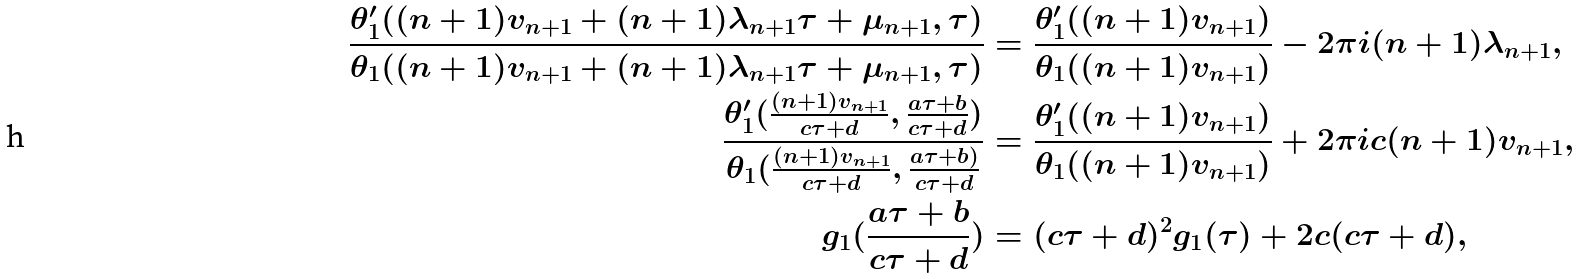Convert formula to latex. <formula><loc_0><loc_0><loc_500><loc_500>\frac { \theta _ { 1 } ^ { \prime } ( ( n + 1 ) v _ { n + 1 } + ( n + 1 ) \lambda _ { n + 1 } \tau + \mu _ { n + 1 } , \tau ) } { \theta _ { 1 } ( ( n + 1 ) v _ { n + 1 } + ( n + 1 ) \lambda _ { n + 1 } \tau + \mu _ { n + 1 } , \tau ) } & = \frac { \theta _ { 1 } ^ { \prime } ( ( n + 1 ) v _ { n + 1 } ) } { \theta _ { 1 } ( ( n + 1 ) v _ { n + 1 } ) } - 2 \pi i ( n + 1 ) \lambda _ { n + 1 } , \\ \frac { \theta _ { 1 } ^ { \prime } ( \frac { ( n + 1 ) v _ { n + 1 } } { c \tau + d } , \frac { a \tau + b } { c \tau + d } ) } { \theta _ { 1 } ( \frac { ( n + 1 ) v _ { n + 1 } } { c \tau + d } , \frac { a \tau + b ) } { c \tau + d } } & = \frac { \theta _ { 1 } ^ { \prime } ( ( n + 1 ) v _ { n + 1 } ) } { \theta _ { 1 } ( ( n + 1 ) v _ { n + 1 } ) } + 2 \pi i c ( n + 1 ) v _ { n + 1 } , \\ g _ { 1 } ( \frac { a \tau + b } { c \tau + d } ) & = ( c \tau + d ) ^ { 2 } g _ { 1 } ( \tau ) + 2 c ( c \tau + d ) ,</formula> 